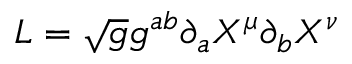Convert formula to latex. <formula><loc_0><loc_0><loc_500><loc_500>L = \sqrt { g } g ^ { a b } \partial _ { a } X ^ { \mu } \partial _ { b } X ^ { \nu }</formula> 